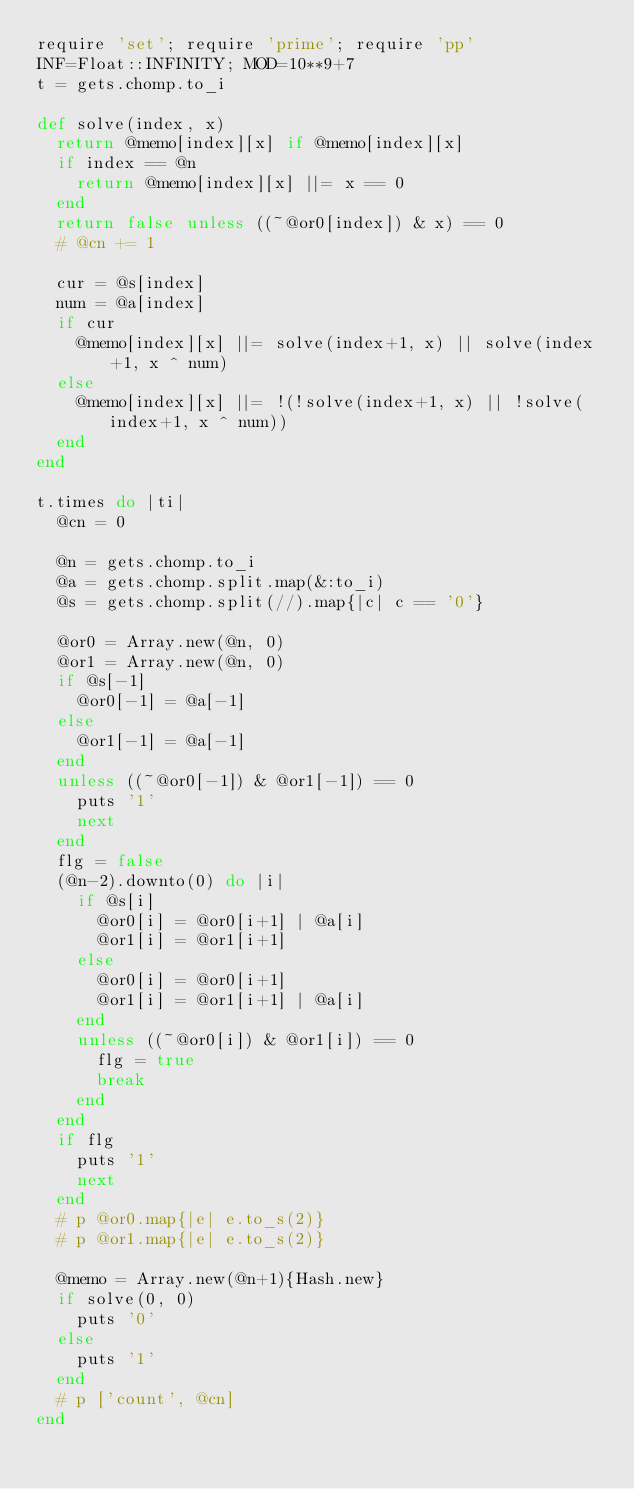<code> <loc_0><loc_0><loc_500><loc_500><_Ruby_>require 'set'; require 'prime'; require 'pp'
INF=Float::INFINITY; MOD=10**9+7
t = gets.chomp.to_i

def solve(index, x)
  return @memo[index][x] if @memo[index][x]
  if index == @n
    return @memo[index][x] ||= x == 0
  end
  return false unless ((~@or0[index]) & x) == 0
  # @cn += 1

  cur = @s[index]
  num = @a[index]
  if cur
    @memo[index][x] ||= solve(index+1, x) || solve(index+1, x ^ num)
  else
    @memo[index][x] ||= !(!solve(index+1, x) || !solve(index+1, x ^ num))
  end
end

t.times do |ti|
  @cn = 0

  @n = gets.chomp.to_i
  @a = gets.chomp.split.map(&:to_i)
  @s = gets.chomp.split(//).map{|c| c == '0'}

  @or0 = Array.new(@n, 0)
  @or1 = Array.new(@n, 0)
  if @s[-1]
    @or0[-1] = @a[-1]
  else
    @or1[-1] = @a[-1]
  end
  unless ((~@or0[-1]) & @or1[-1]) == 0
    puts '1'
    next
  end
  flg = false
  (@n-2).downto(0) do |i|
    if @s[i]
      @or0[i] = @or0[i+1] | @a[i]
      @or1[i] = @or1[i+1]
    else
      @or0[i] = @or0[i+1]
      @or1[i] = @or1[i+1] | @a[i]
    end
    unless ((~@or0[i]) & @or1[i]) == 0
      flg = true
      break
    end
  end
  if flg
    puts '1'
    next
  end
  # p @or0.map{|e| e.to_s(2)}
  # p @or1.map{|e| e.to_s(2)}

  @memo = Array.new(@n+1){Hash.new}
  if solve(0, 0)
    puts '0'
  else
    puts '1'
  end
  # p ['count', @cn]
end
</code> 